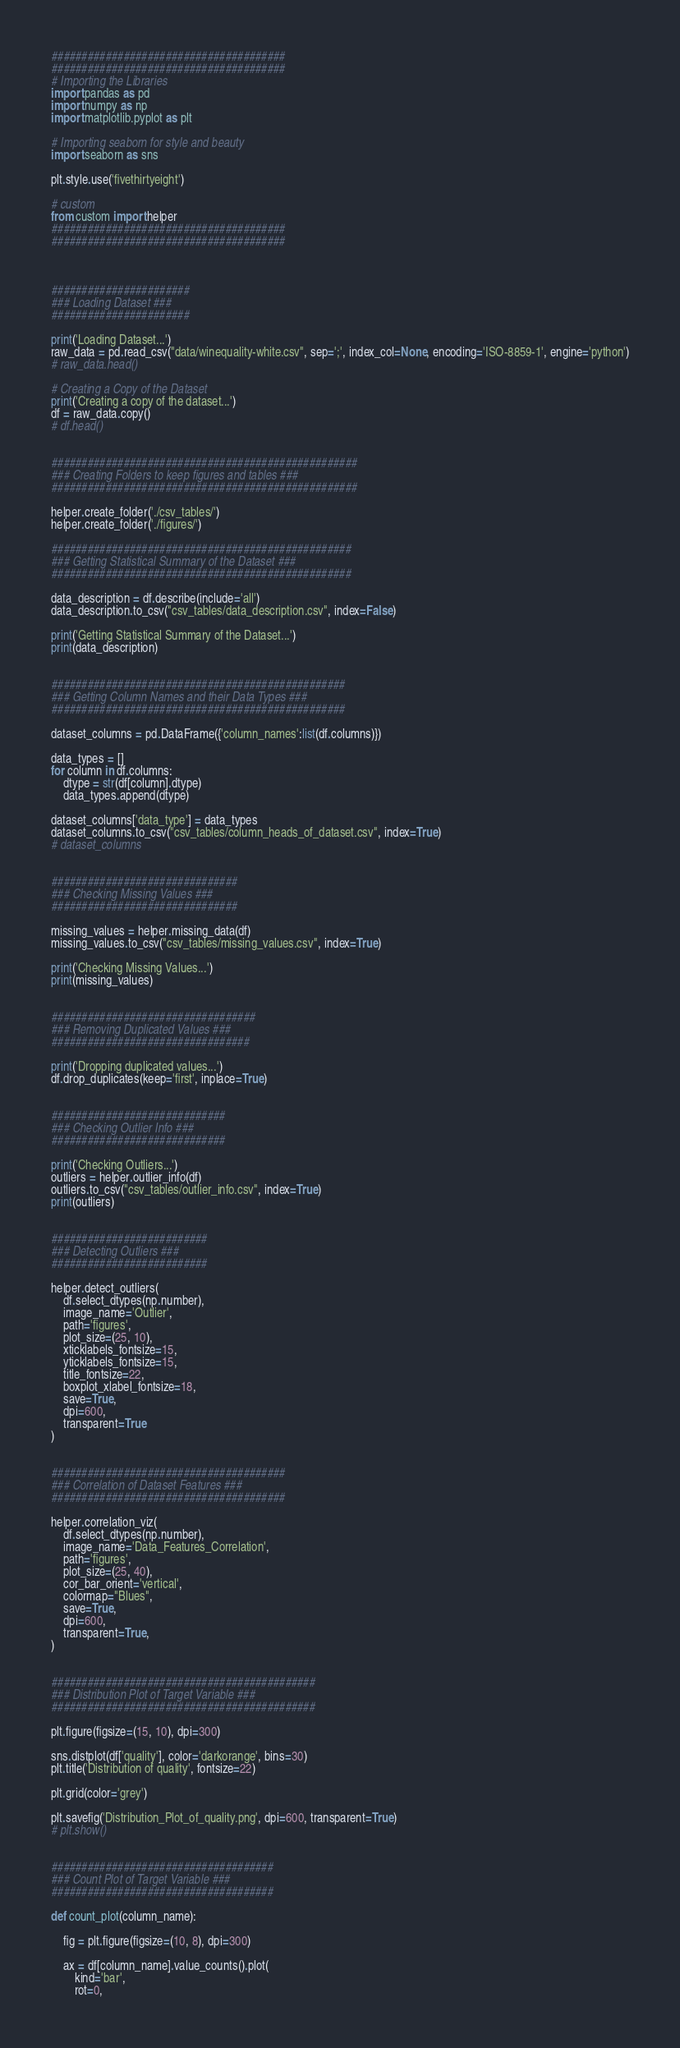Convert code to text. <code><loc_0><loc_0><loc_500><loc_500><_Python_>
#######################################
#######################################
# Importing the Libraries
import pandas as pd
import numpy as np
import matplotlib.pyplot as plt

# Importing seaborn for style and beauty
import seaborn as sns

plt.style.use('fivethirtyeight')

# custom
from custom import helper
#######################################
#######################################



#######################
### Loading Dataset ###
#######################

print('Loading Dataset...')
raw_data = pd.read_csv("data/winequality-white.csv", sep=';', index_col=None, encoding='ISO-8859-1', engine='python')
# raw_data.head()

# Creating a Copy of the Dataset
print('Creating a copy of the dataset...')
df = raw_data.copy()
# df.head()


###################################################
### Creating Folders to keep figures and tables ###
###################################################

helper.create_folder('./csv_tables/')
helper.create_folder('./figures/')

##################################################
### Getting Statistical Summary of the Dataset ###
##################################################

data_description = df.describe(include='all')
data_description.to_csv("csv_tables/data_description.csv", index=False)

print('Getting Statistical Summary of the Dataset...')
print(data_description)


#################################################
### Getting Column Names and their Data Types ###
#################################################

dataset_columns = pd.DataFrame({'column_names':list(df.columns)})

data_types = []
for column in df.columns:
    dtype = str(df[column].dtype)
    data_types.append(dtype)

dataset_columns['data_type'] = data_types
dataset_columns.to_csv("csv_tables/column_heads_of_dataset.csv", index=True)
# dataset_columns


###############################
### Checking Missing Values ###
###############################

missing_values = helper.missing_data(df)
missing_values.to_csv("csv_tables/missing_values.csv", index=True)

print('Checking Missing Values...')
print(missing_values)


##################################
### Removing Duplicated Values ###
#################################

print('Dropping duplicated values...')
df.drop_duplicates(keep='first', inplace=True)


#############################
### Checking Outlier Info ###
#############################

print('Checking Outliers...')
outliers = helper.outlier_info(df)
outliers.to_csv("csv_tables/outlier_info.csv", index=True)
print(outliers)


##########################
### Detecting Outliers ###
##########################

helper.detect_outliers(
    df.select_dtypes(np.number),
    image_name='Outlier',
    path='figures',
    plot_size=(25, 10), 
    xticklabels_fontsize=15, 
    yticklabels_fontsize=15, 
    title_fontsize=22, 
    boxplot_xlabel_fontsize=18, 
    save=True, 
    dpi=600, 
    transparent=True
)


#######################################
### Correlation of Dataset Features ###
#######################################

helper.correlation_viz(
    df.select_dtypes(np.number),
    image_name='Data_Features_Correlation',
    path='figures',
    plot_size=(25, 40),
    cor_bar_orient='vertical',
    colormap="Blues",
    save=True,
    dpi=600,
    transparent=True,
)


############################################
### Distribution Plot of Target Variable ###
############################################

plt.figure(figsize=(15, 10), dpi=300)

sns.distplot(df['quality'], color='darkorange', bins=30)
plt.title('Distribution of quality', fontsize=22)

plt.grid(color='grey')

plt.savefig('Distribution_Plot_of_quality.png', dpi=600, transparent=True)
# plt.show()


#####################################
### Count Plot of Target Variable ###
#####################################

def count_plot(column_name):

    fig = plt.figure(figsize=(10, 8), dpi=300)

    ax = df[column_name].value_counts().plot(
        kind='bar', 
        rot=0, </code> 